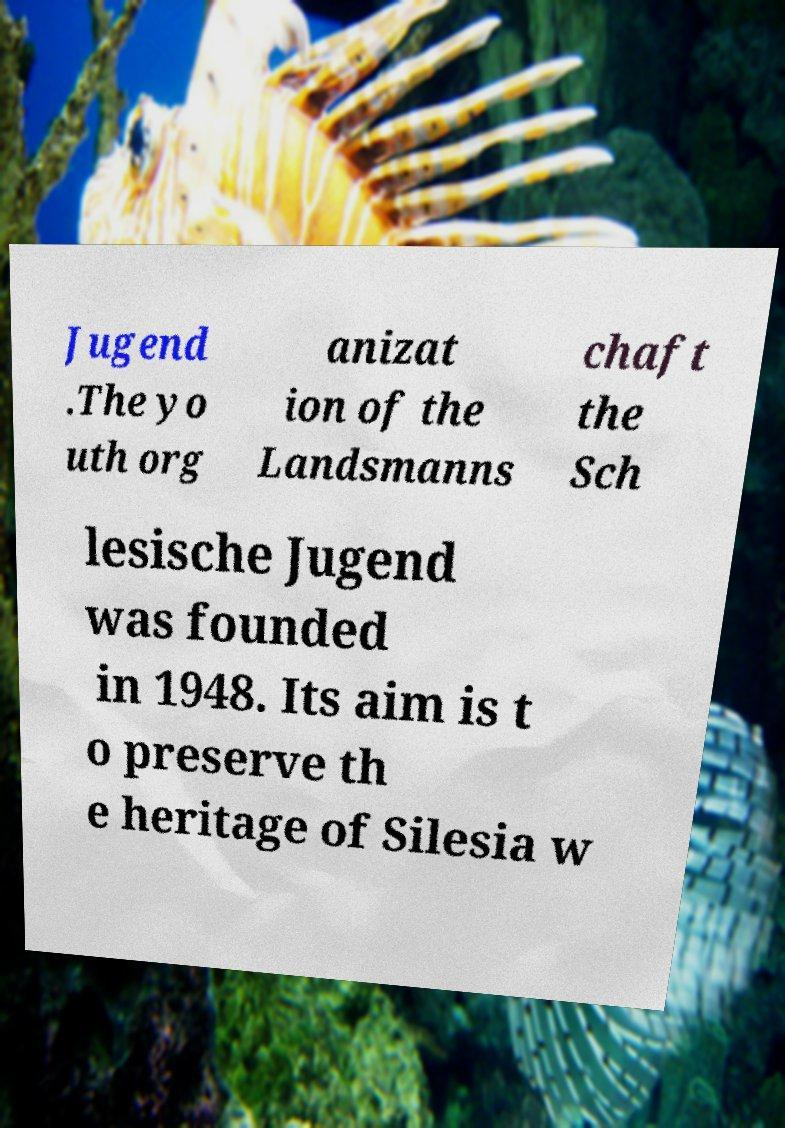Could you extract and type out the text from this image? Jugend .The yo uth org anizat ion of the Landsmanns chaft the Sch lesische Jugend was founded in 1948. Its aim is t o preserve th e heritage of Silesia w 